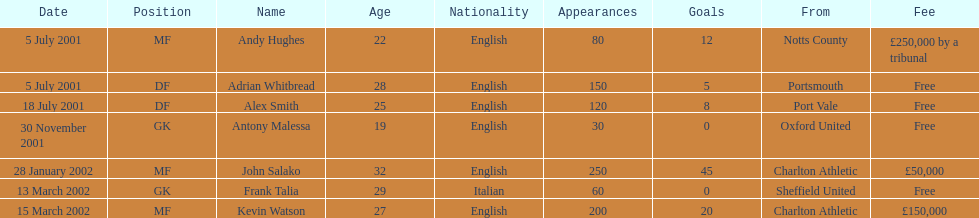Who transferred before 1 august 2001? Andy Hughes, Adrian Whitbread, Alex Smith. 